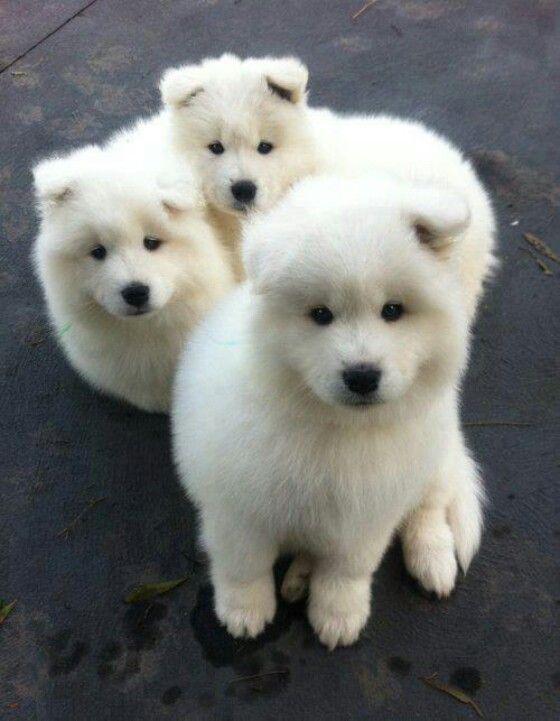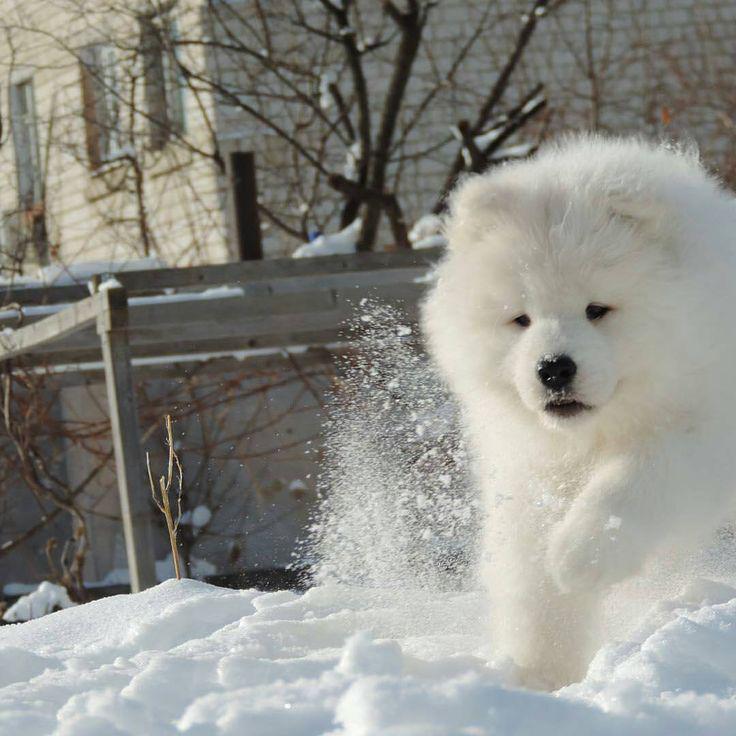The first image is the image on the left, the second image is the image on the right. Given the left and right images, does the statement "There are three Samoyed puppies in the left image." hold true? Answer yes or no. Yes. The first image is the image on the left, the second image is the image on the right. Given the left and right images, does the statement "An image shows one person behind three white dogs." hold true? Answer yes or no. No. 